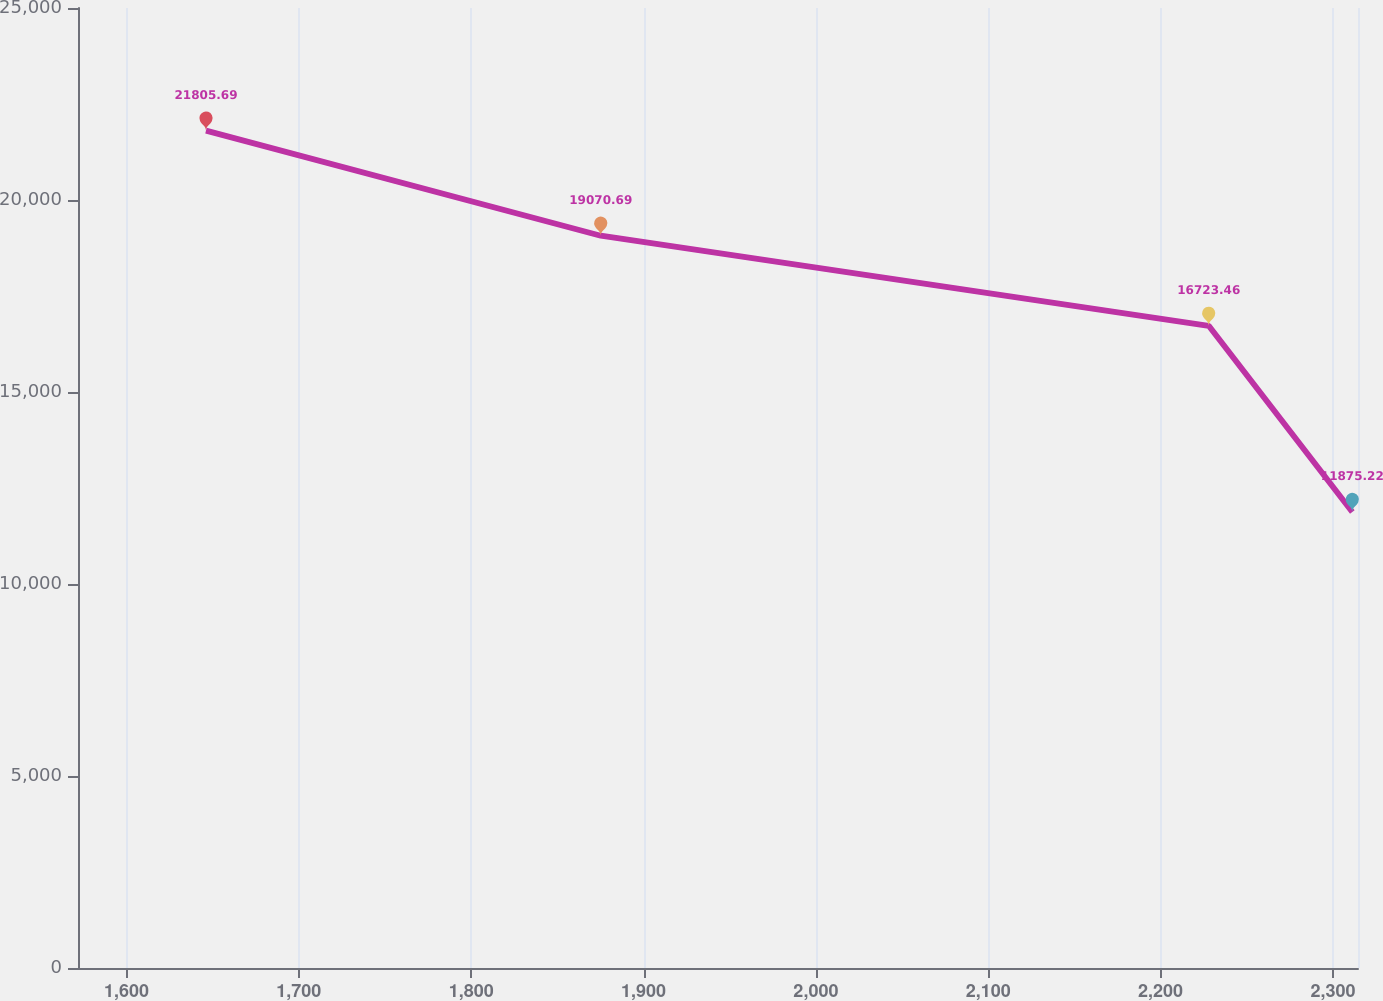Convert chart. <chart><loc_0><loc_0><loc_500><loc_500><line_chart><ecel><fcel>Unnamed: 1<nl><fcel>1646.12<fcel>21805.7<nl><fcel>1875.17<fcel>19070.7<nl><fcel>2227.94<fcel>16723.5<nl><fcel>2311.25<fcel>11875.2<nl><fcel>2388.82<fcel>13417.7<nl></chart> 